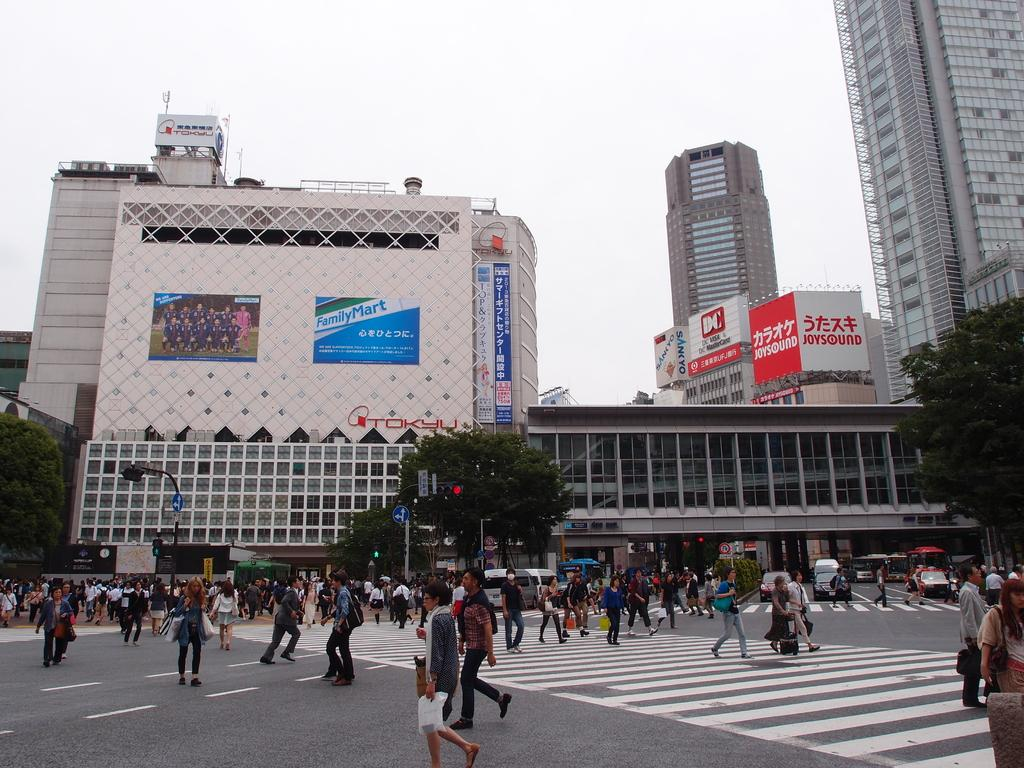What are the people in the image doing? There is a group of people walking in the image. What else can be seen on the road in the image? There are vehicles on the road in the image. What can be seen in the background of the image? There are trees, buildings, plants, banners, poles, and some objects in the background of the image. What part of the natural environment is visible in the image? The sky is visible in the background of the image. What type of brush can be seen in the hands of the people walking in the image? There is no brush present in the image; the people are simply walking. 